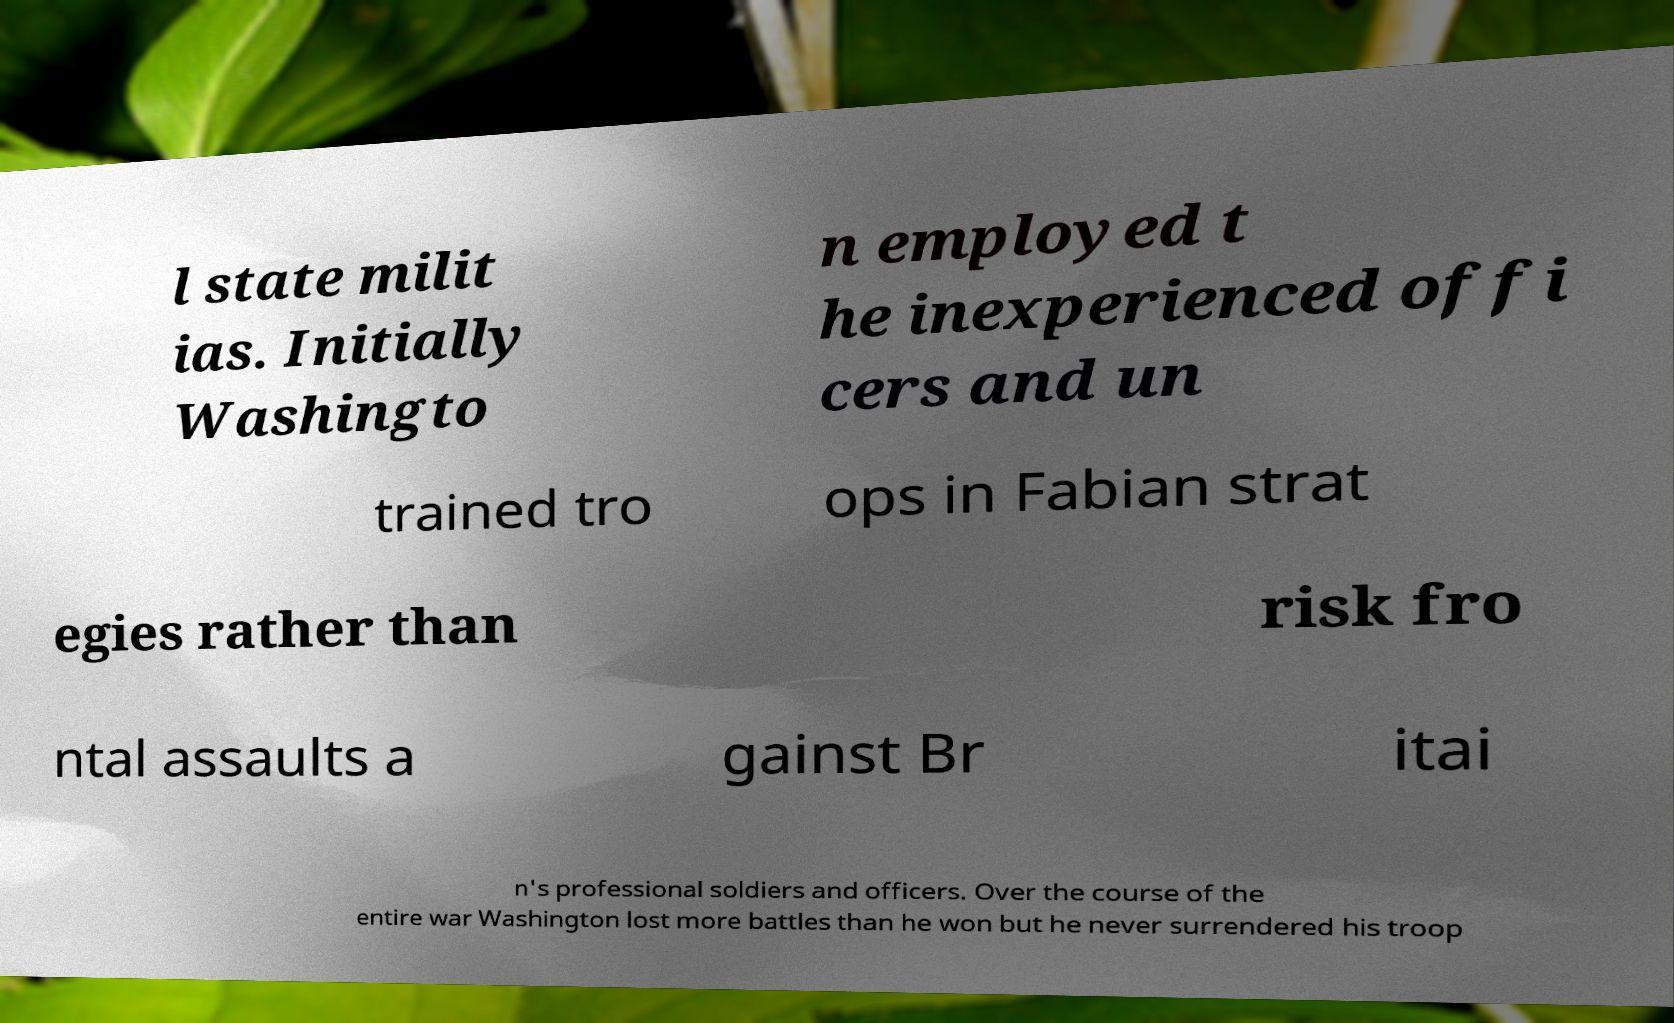Please identify and transcribe the text found in this image. l state milit ias. Initially Washingto n employed t he inexperienced offi cers and un trained tro ops in Fabian strat egies rather than risk fro ntal assaults a gainst Br itai n's professional soldiers and officers. Over the course of the entire war Washington lost more battles than he won but he never surrendered his troop 